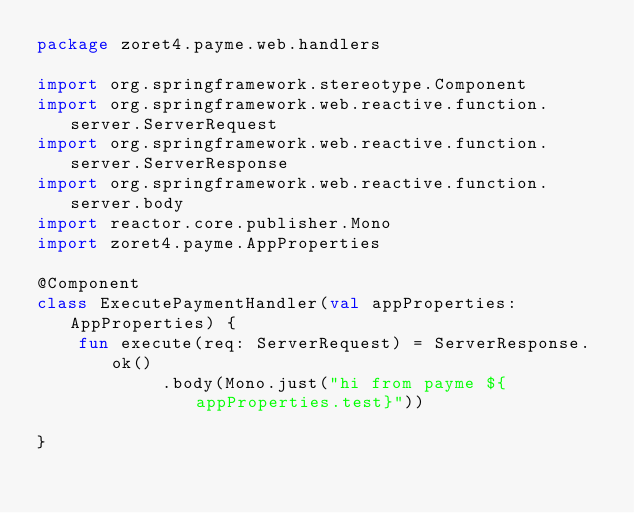<code> <loc_0><loc_0><loc_500><loc_500><_Kotlin_>package zoret4.payme.web.handlers

import org.springframework.stereotype.Component
import org.springframework.web.reactive.function.server.ServerRequest
import org.springframework.web.reactive.function.server.ServerResponse
import org.springframework.web.reactive.function.server.body
import reactor.core.publisher.Mono
import zoret4.payme.AppProperties

@Component
class ExecutePaymentHandler(val appProperties: AppProperties) {
    fun execute(req: ServerRequest) = ServerResponse.ok()
            .body(Mono.just("hi from payme ${appProperties.test}"))

}</code> 